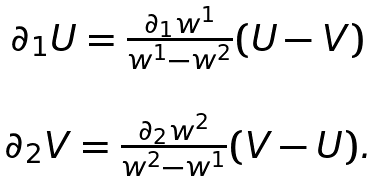<formula> <loc_0><loc_0><loc_500><loc_500>\begin{array} { c } \partial _ { 1 } { U } = \frac { \partial _ { 1 } w ^ { 1 } } { w ^ { 1 } - w ^ { 2 } } ( { U } - { V } ) \\ \ \\ \partial _ { 2 } { V } = \frac { \partial _ { 2 } w ^ { 2 } } { w ^ { 2 } - w ^ { 1 } } ( { V } - { U } ) . \\ \end{array}</formula> 